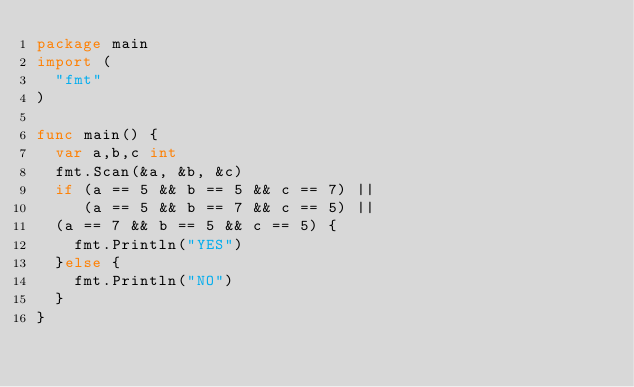Convert code to text. <code><loc_0><loc_0><loc_500><loc_500><_Go_>package main
import (
  "fmt"
)

func main() {
  var a,b,c int
  fmt.Scan(&a, &b, &c)
  if (a == 5 && b == 5 && c == 7) ||
     (a == 5 && b == 7 && c == 5) ||
  (a == 7 && b == 5 && c == 5) {
    fmt.Println("YES")
  }else {
    fmt.Println("NO")
  }
}</code> 